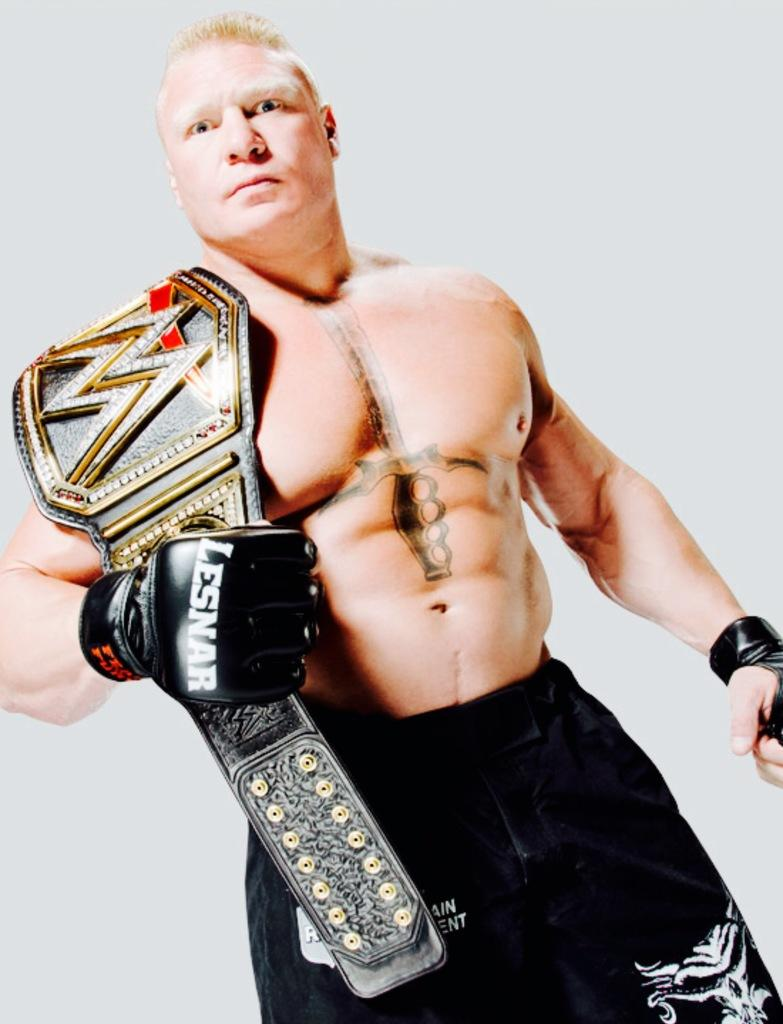What is the main subject of the image? There is a person in the image. What is the person wearing? The person is wearing a black color shirt and black color gloves. Is there any accessory visible on the person? Yes, the person has a belt on his shoulder. What is the person's posture in the image? The person is standing. What is the color of the background in the image? The background of the image is white in color. Can you see any flames in the image? No, there are no flames present in the image. Are there any beds visible in the image? No, there are no beds present in the image. 